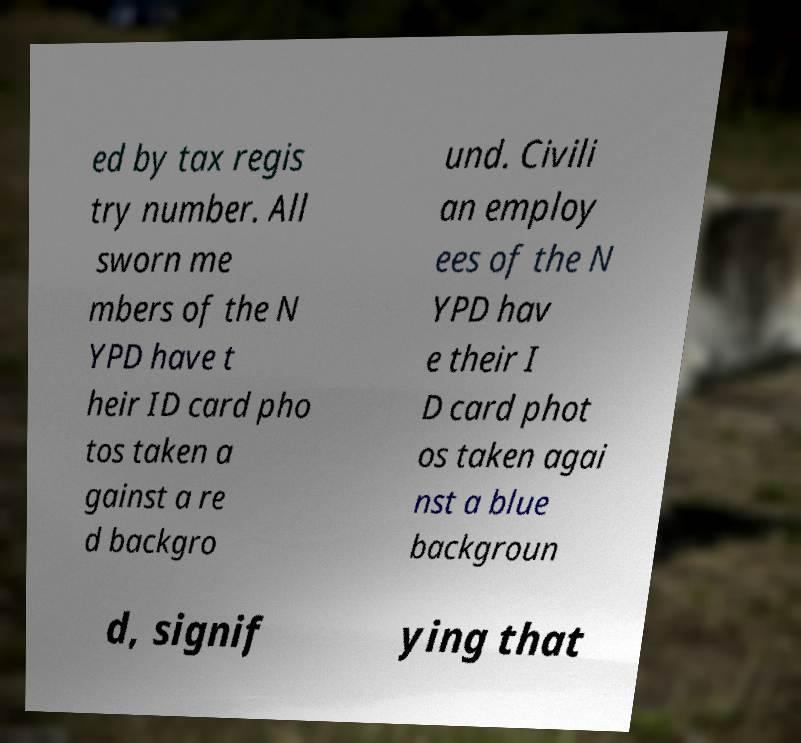There's text embedded in this image that I need extracted. Can you transcribe it verbatim? ed by tax regis try number. All sworn me mbers of the N YPD have t heir ID card pho tos taken a gainst a re d backgro und. Civili an employ ees of the N YPD hav e their I D card phot os taken agai nst a blue backgroun d, signif ying that 